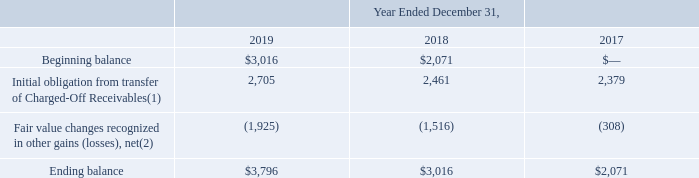GreenSky, Inc.
NOTES TO CONSOLIDATED FINANCIAL STATEMENTS — (Continued)
(United States Dollars in thousands, except per share data, unless otherwise stated)
The following table reconciles the beginning and ending fair value measurements of our servicing liabilities associated with transferring our rights to Charged-Off Receivables during the periods presented.
(1) Recognized in other gains (losses), net in the Consolidated Statements of Operations.
(2) Represents the reduction of our servicing liabilities due to the passage of time and collection of loan payments.
What does the net Fair value changes recognized in other gains (losses) represent? The reduction of our servicing liabilities due to the passage of time and collection of loan payments. What was the beginning balance in 2018?
Answer scale should be: thousand. 2,071. Which years does the table show? 2019, 2018, 2017. Which years did the ending balance exceed $3,000 thousand? (2019:3,796),(2018:3,016)
Answer: 2019, 2018. What was the change in the beginning balance between 2018 and 2019?
Answer scale should be: thousand. 3,016-2,071
Answer: 945. What was the percentage change in the Initial obligation from transfer of Charged-Off Receivables between 2018 and 2019?
Answer scale should be: percent. (2,705-2,461)/2,461
Answer: 9.91. 